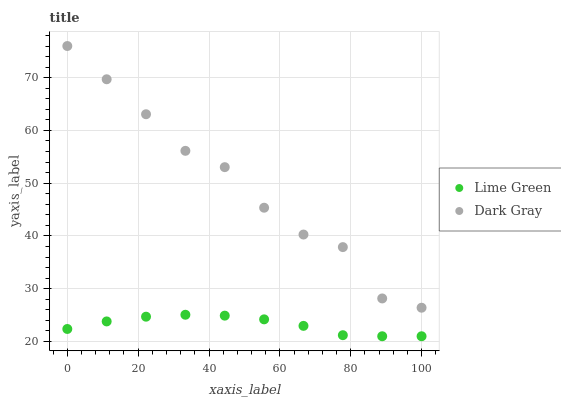Does Lime Green have the minimum area under the curve?
Answer yes or no. Yes. Does Dark Gray have the maximum area under the curve?
Answer yes or no. Yes. Does Lime Green have the maximum area under the curve?
Answer yes or no. No. Is Lime Green the smoothest?
Answer yes or no. Yes. Is Dark Gray the roughest?
Answer yes or no. Yes. Is Lime Green the roughest?
Answer yes or no. No. Does Lime Green have the lowest value?
Answer yes or no. Yes. Does Dark Gray have the highest value?
Answer yes or no. Yes. Does Lime Green have the highest value?
Answer yes or no. No. Is Lime Green less than Dark Gray?
Answer yes or no. Yes. Is Dark Gray greater than Lime Green?
Answer yes or no. Yes. Does Lime Green intersect Dark Gray?
Answer yes or no. No. 